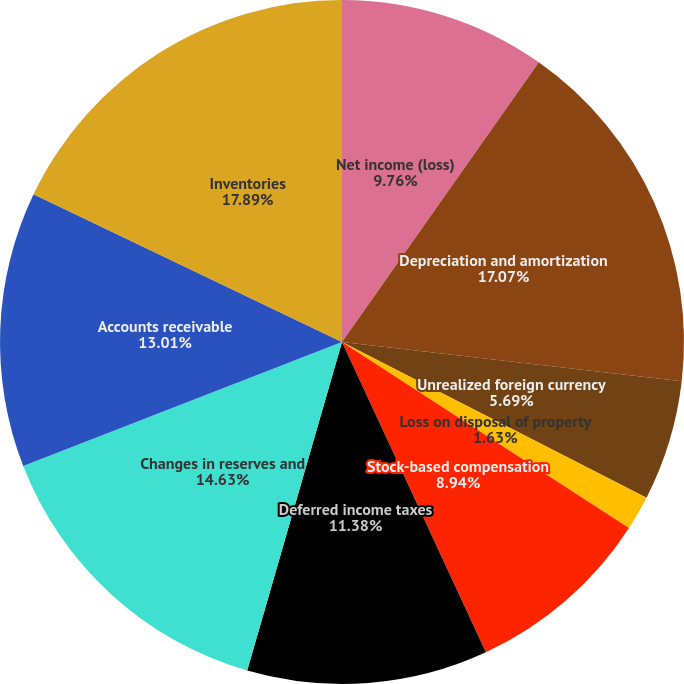Convert chart to OTSL. <chart><loc_0><loc_0><loc_500><loc_500><pie_chart><fcel>Net income (loss)<fcel>Depreciation and amortization<fcel>Unrealized foreign currency<fcel>Loss on disposal of property<fcel>Stock-based compensation<fcel>Excess tax benefit (loss) from<fcel>Deferred income taxes<fcel>Changes in reserves and<fcel>Accounts receivable<fcel>Inventories<nl><fcel>9.76%<fcel>17.07%<fcel>5.69%<fcel>1.63%<fcel>8.94%<fcel>0.0%<fcel>11.38%<fcel>14.63%<fcel>13.01%<fcel>17.89%<nl></chart> 